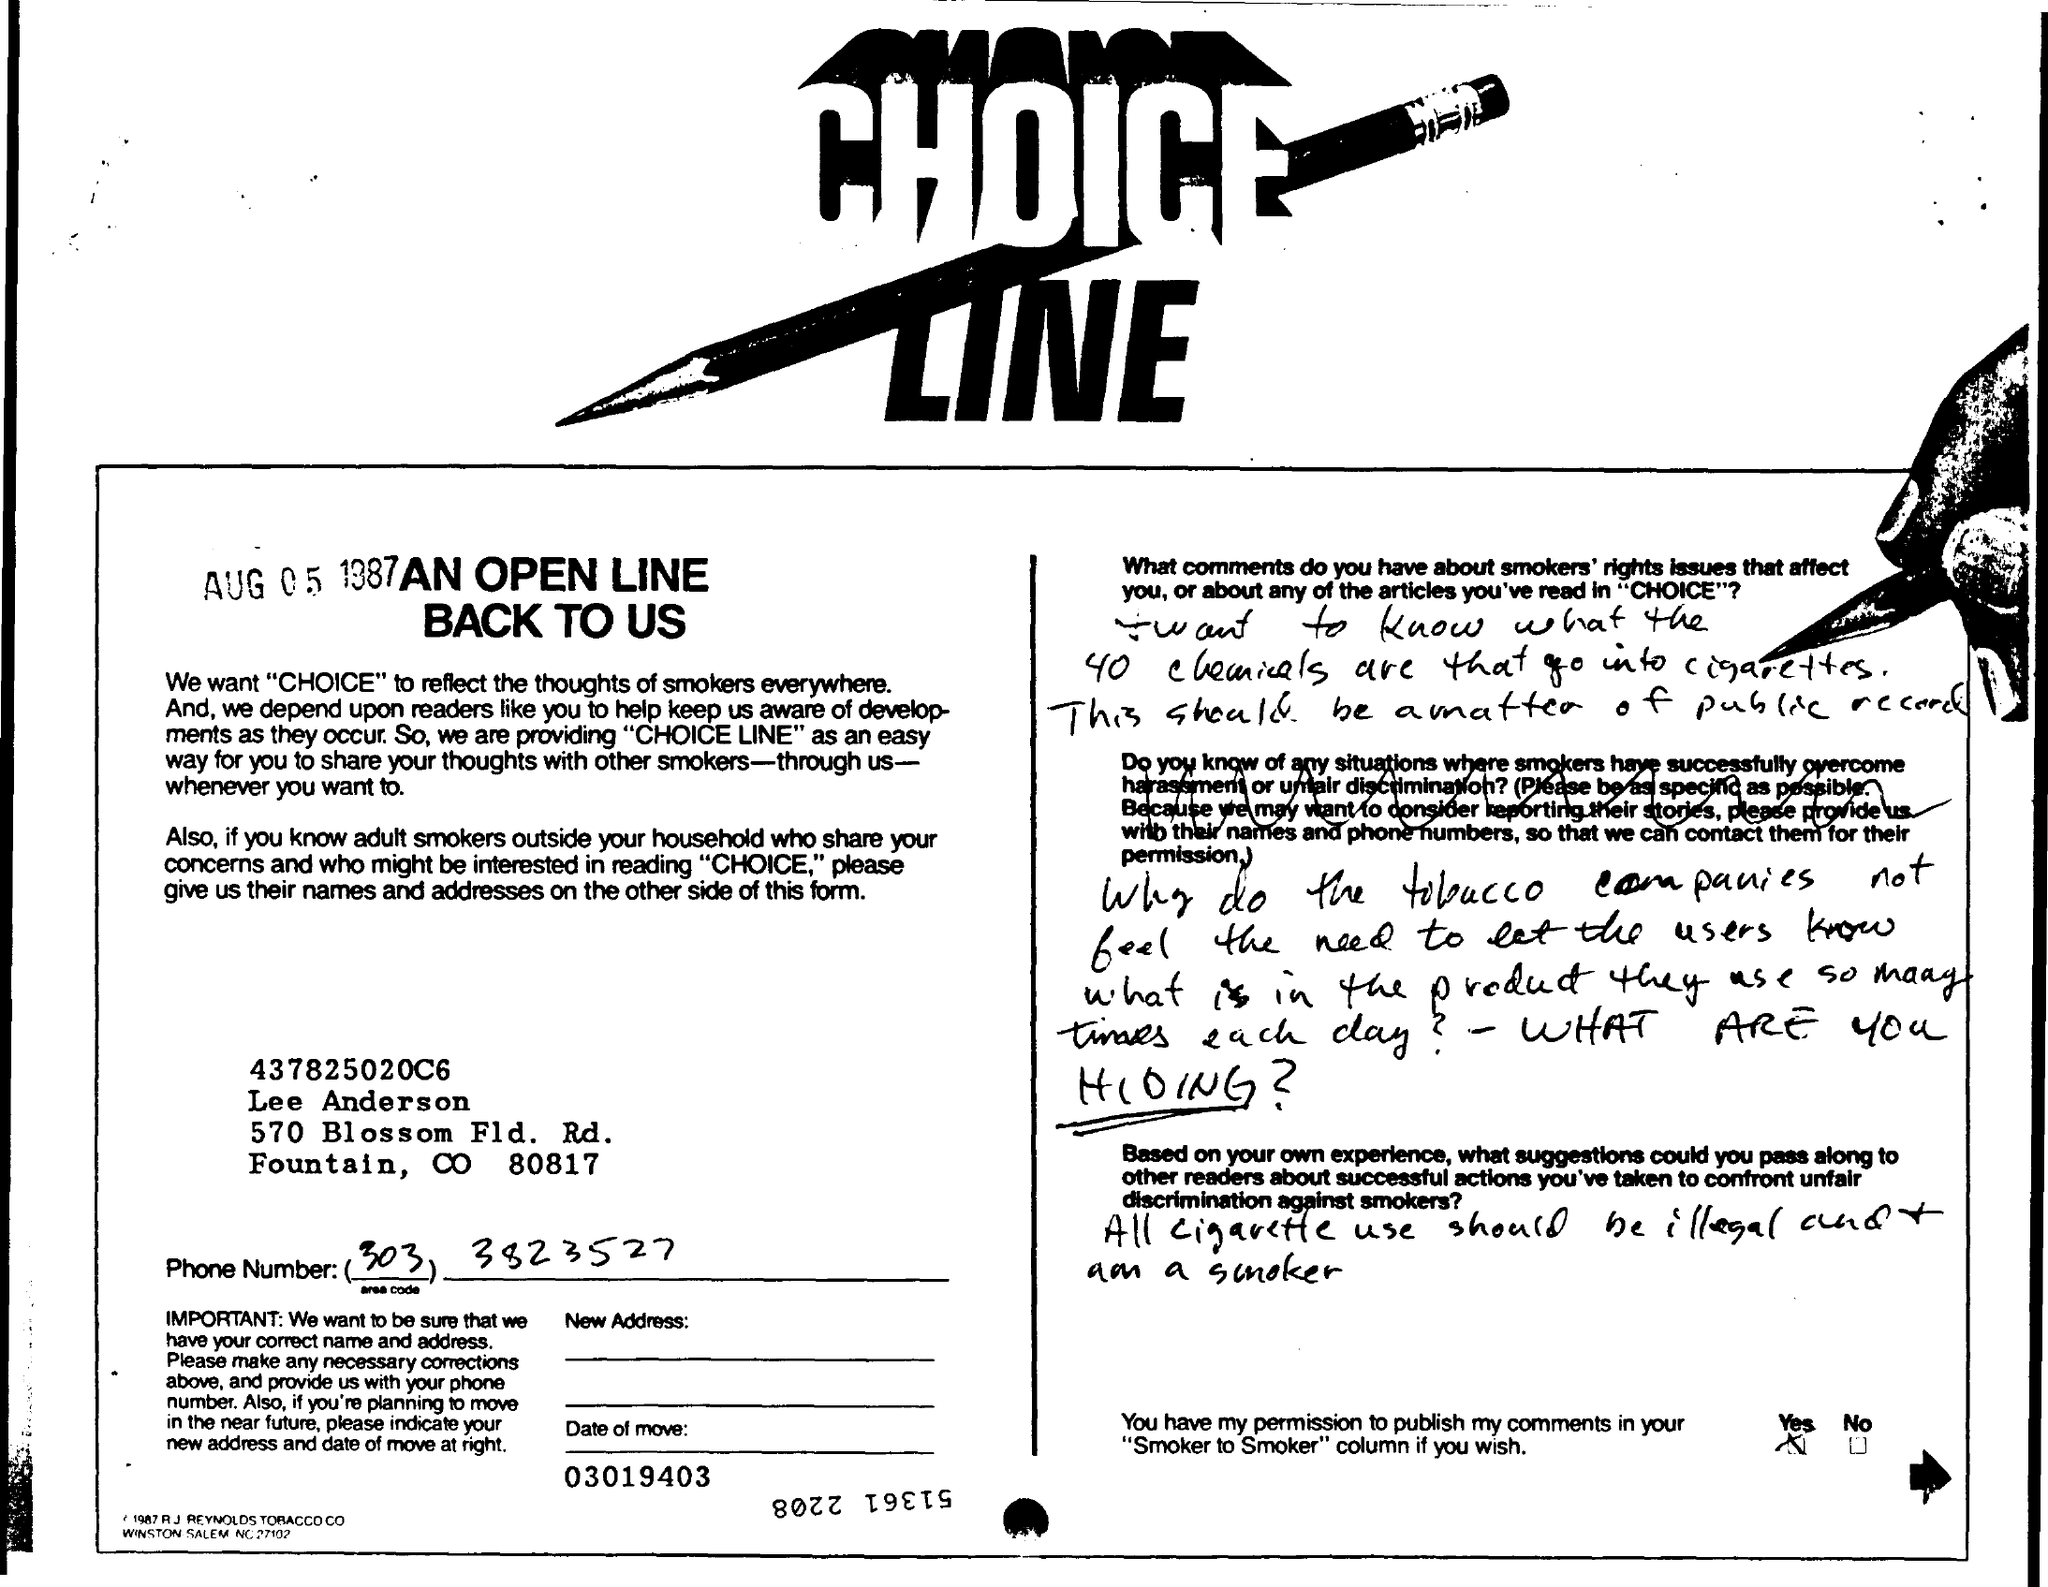Highlight a few significant elements in this photo. The title of the document is [insert title here], a choice line that [insert any additional information here]. The document contains the date of August 5, 1987. 